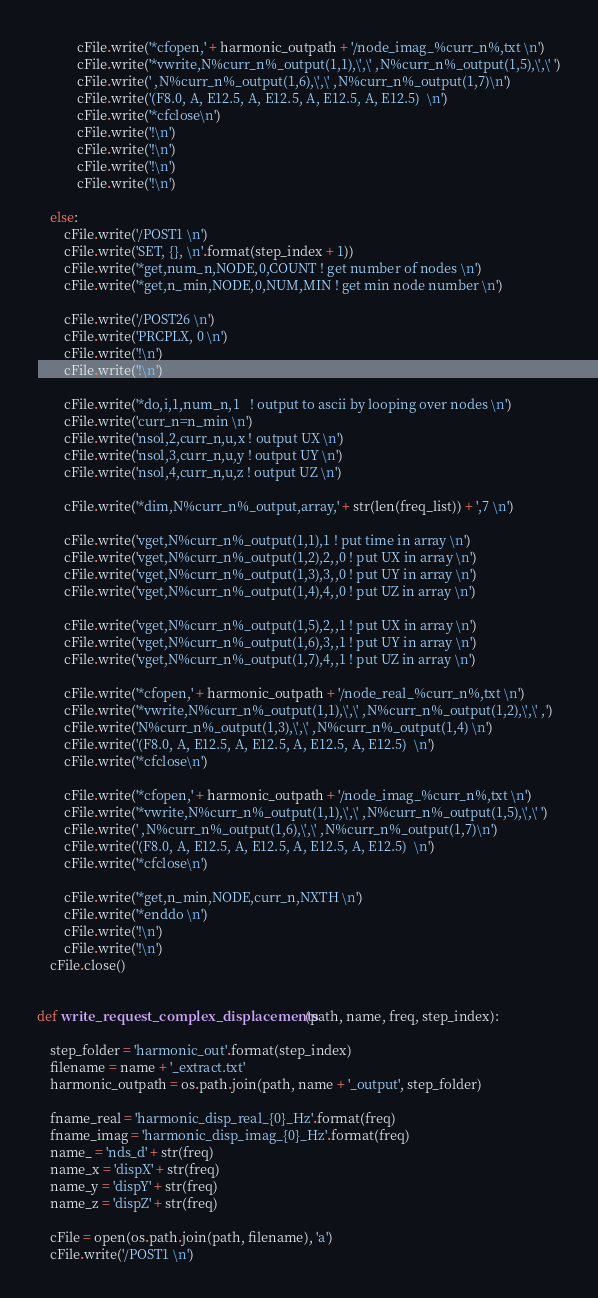<code> <loc_0><loc_0><loc_500><loc_500><_Python_>
            cFile.write('*cfopen,' + harmonic_outpath + '/node_imag_%curr_n%,txt \n')
            cFile.write('*vwrite,N%curr_n%_output(1,1),\',\' ,N%curr_n%_output(1,5),\',\' ')
            cFile.write(' ,N%curr_n%_output(1,6),\',\' ,N%curr_n%_output(1,7)\n')
            cFile.write('(F8.0, A, E12.5, A, E12.5, A, E12.5, A, E12.5)  \n')
            cFile.write('*cfclose\n')
            cFile.write('!\n')
            cFile.write('!\n')
            cFile.write('!\n')
            cFile.write('!\n')

    else:
        cFile.write('/POST1 \n')
        cFile.write('SET, {}, \n'.format(step_index + 1))
        cFile.write('*get,num_n,NODE,0,COUNT ! get number of nodes \n')
        cFile.write('*get,n_min,NODE,0,NUM,MIN ! get min node number \n')

        cFile.write('/POST26 \n')
        cFile.write('PRCPLX, 0 \n')
        cFile.write('!\n')
        cFile.write('!\n')

        cFile.write('*do,i,1,num_n,1   ! output to ascii by looping over nodes \n')
        cFile.write('curr_n=n_min \n')
        cFile.write('nsol,2,curr_n,u,x ! output UX \n')
        cFile.write('nsol,3,curr_n,u,y ! output UY \n')
        cFile.write('nsol,4,curr_n,u,z ! output UZ \n')

        cFile.write('*dim,N%curr_n%_output,array,' + str(len(freq_list)) + ',7 \n')

        cFile.write('vget,N%curr_n%_output(1,1),1 ! put time in array \n')
        cFile.write('vget,N%curr_n%_output(1,2),2,,0 ! put UX in array \n')
        cFile.write('vget,N%curr_n%_output(1,3),3,,0 ! put UY in array \n')
        cFile.write('vget,N%curr_n%_output(1,4),4,,0 ! put UZ in array \n')

        cFile.write('vget,N%curr_n%_output(1,5),2,,1 ! put UX in array \n')
        cFile.write('vget,N%curr_n%_output(1,6),3,,1 ! put UY in array \n')
        cFile.write('vget,N%curr_n%_output(1,7),4,,1 ! put UZ in array \n')

        cFile.write('*cfopen,' + harmonic_outpath + '/node_real_%curr_n%,txt \n')
        cFile.write('*vwrite,N%curr_n%_output(1,1),\',\' ,N%curr_n%_output(1,2),\',\' ,')
        cFile.write('N%curr_n%_output(1,3),\',\' ,N%curr_n%_output(1,4) \n')
        cFile.write('(F8.0, A, E12.5, A, E12.5, A, E12.5, A, E12.5)  \n')
        cFile.write('*cfclose\n')

        cFile.write('*cfopen,' + harmonic_outpath + '/node_imag_%curr_n%,txt \n')
        cFile.write('*vwrite,N%curr_n%_output(1,1),\',\' ,N%curr_n%_output(1,5),\',\' ')
        cFile.write(' ,N%curr_n%_output(1,6),\',\' ,N%curr_n%_output(1,7)\n')
        cFile.write('(F8.0, A, E12.5, A, E12.5, A, E12.5, A, E12.5)  \n')
        cFile.write('*cfclose\n')

        cFile.write('*get,n_min,NODE,curr_n,NXTH \n')
        cFile.write('*enddo \n')
        cFile.write('!\n')
        cFile.write('!\n')
    cFile.close()


def write_request_complex_displacements(path, name, freq, step_index):

    step_folder = 'harmonic_out'.format(step_index)
    filename = name + '_extract.txt'
    harmonic_outpath = os.path.join(path, name + '_output', step_folder)

    fname_real = 'harmonic_disp_real_{0}_Hz'.format(freq)
    fname_imag = 'harmonic_disp_imag_{0}_Hz'.format(freq)
    name_ = 'nds_d' + str(freq)
    name_x = 'dispX' + str(freq)
    name_y = 'dispY' + str(freq)
    name_z = 'dispZ' + str(freq)

    cFile = open(os.path.join(path, filename), 'a')
    cFile.write('/POST1 \n')</code> 